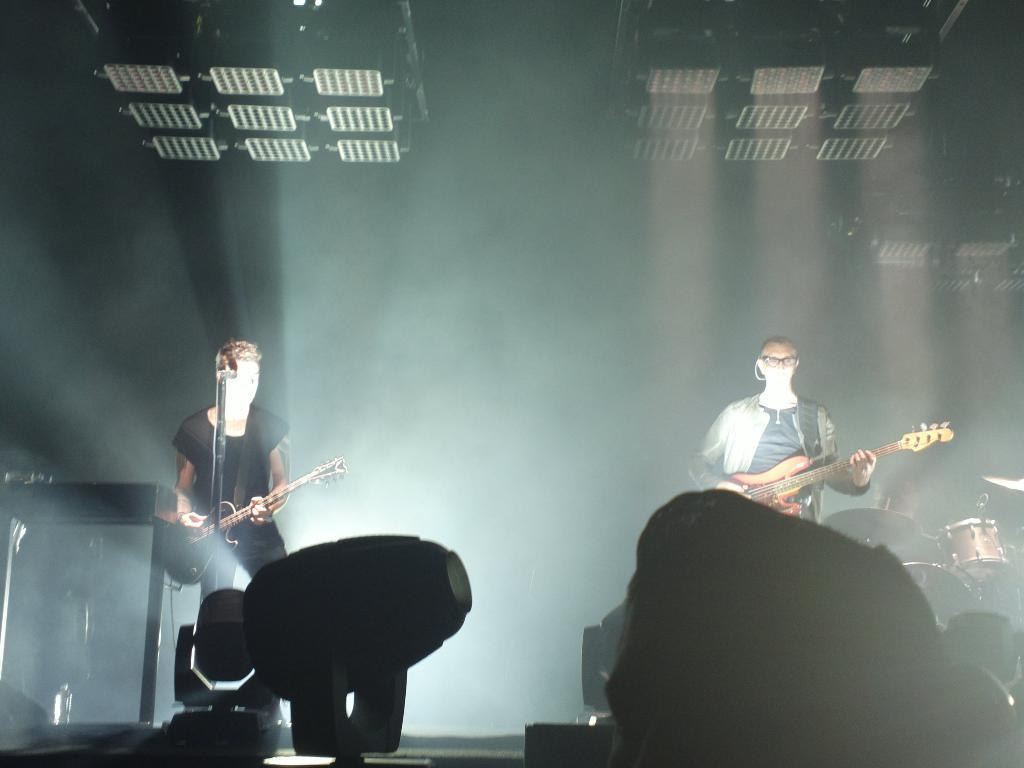How many people are on the dias in the image? There are two persons standing on the dias. What is the person on the left doing? The person on the left is playing a guitar. What is the person on the right wearing? The person on the right is wearing a black t-shirt. What is the person on the right doing? The person on the right is also playing a guitar. Can you tell me what game the baby is playing in the image? There is no baby present in the image, and therefore no game can be observed. 